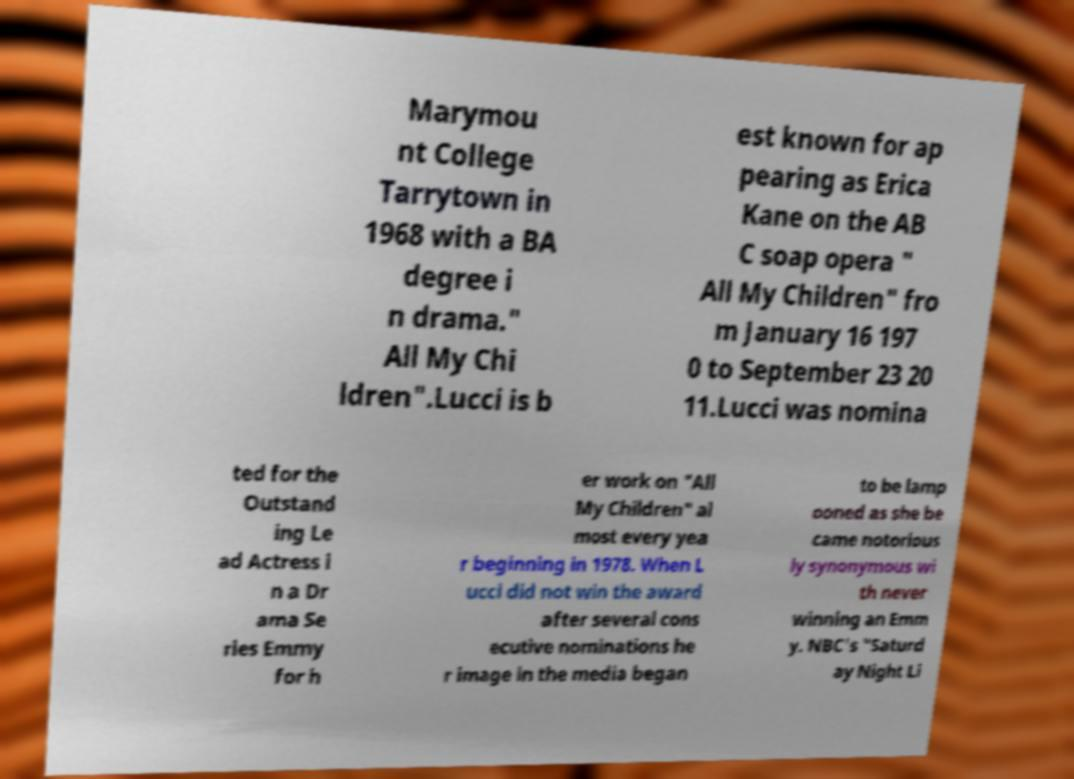Please identify and transcribe the text found in this image. Marymou nt College Tarrytown in 1968 with a BA degree i n drama." All My Chi ldren".Lucci is b est known for ap pearing as Erica Kane on the AB C soap opera " All My Children" fro m January 16 197 0 to September 23 20 11.Lucci was nomina ted for the Outstand ing Le ad Actress i n a Dr ama Se ries Emmy for h er work on "All My Children" al most every yea r beginning in 1978. When L ucci did not win the award after several cons ecutive nominations he r image in the media began to be lamp ooned as she be came notorious ly synonymous wi th never winning an Emm y. NBC's "Saturd ay Night Li 